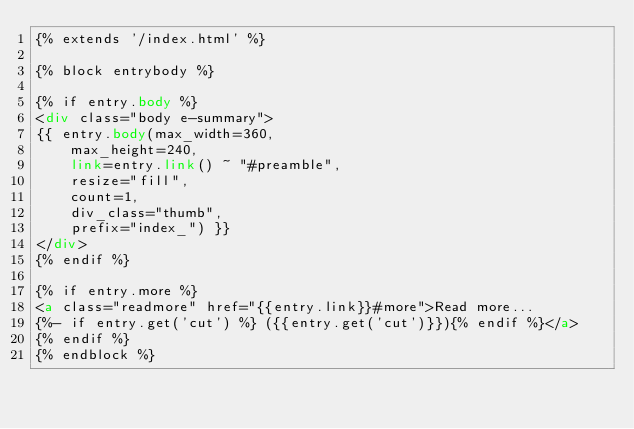<code> <loc_0><loc_0><loc_500><loc_500><_HTML_>{% extends '/index.html' %}

{% block entrybody %}

{% if entry.body %}
<div class="body e-summary">
{{ entry.body(max_width=360,
    max_height=240,
    link=entry.link() ~ "#preamble",
    resize="fill",
    count=1,
    div_class="thumb",
    prefix="index_") }}
</div>
{% endif %}

{% if entry.more %}
<a class="readmore" href="{{entry.link}}#more">Read more...
{%- if entry.get('cut') %} ({{entry.get('cut')}}){% endif %}</a>
{% endif %}
{% endblock %}
</code> 